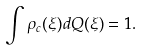<formula> <loc_0><loc_0><loc_500><loc_500>\int \rho _ { c } ( \xi ) d Q ( \xi ) = 1 .</formula> 